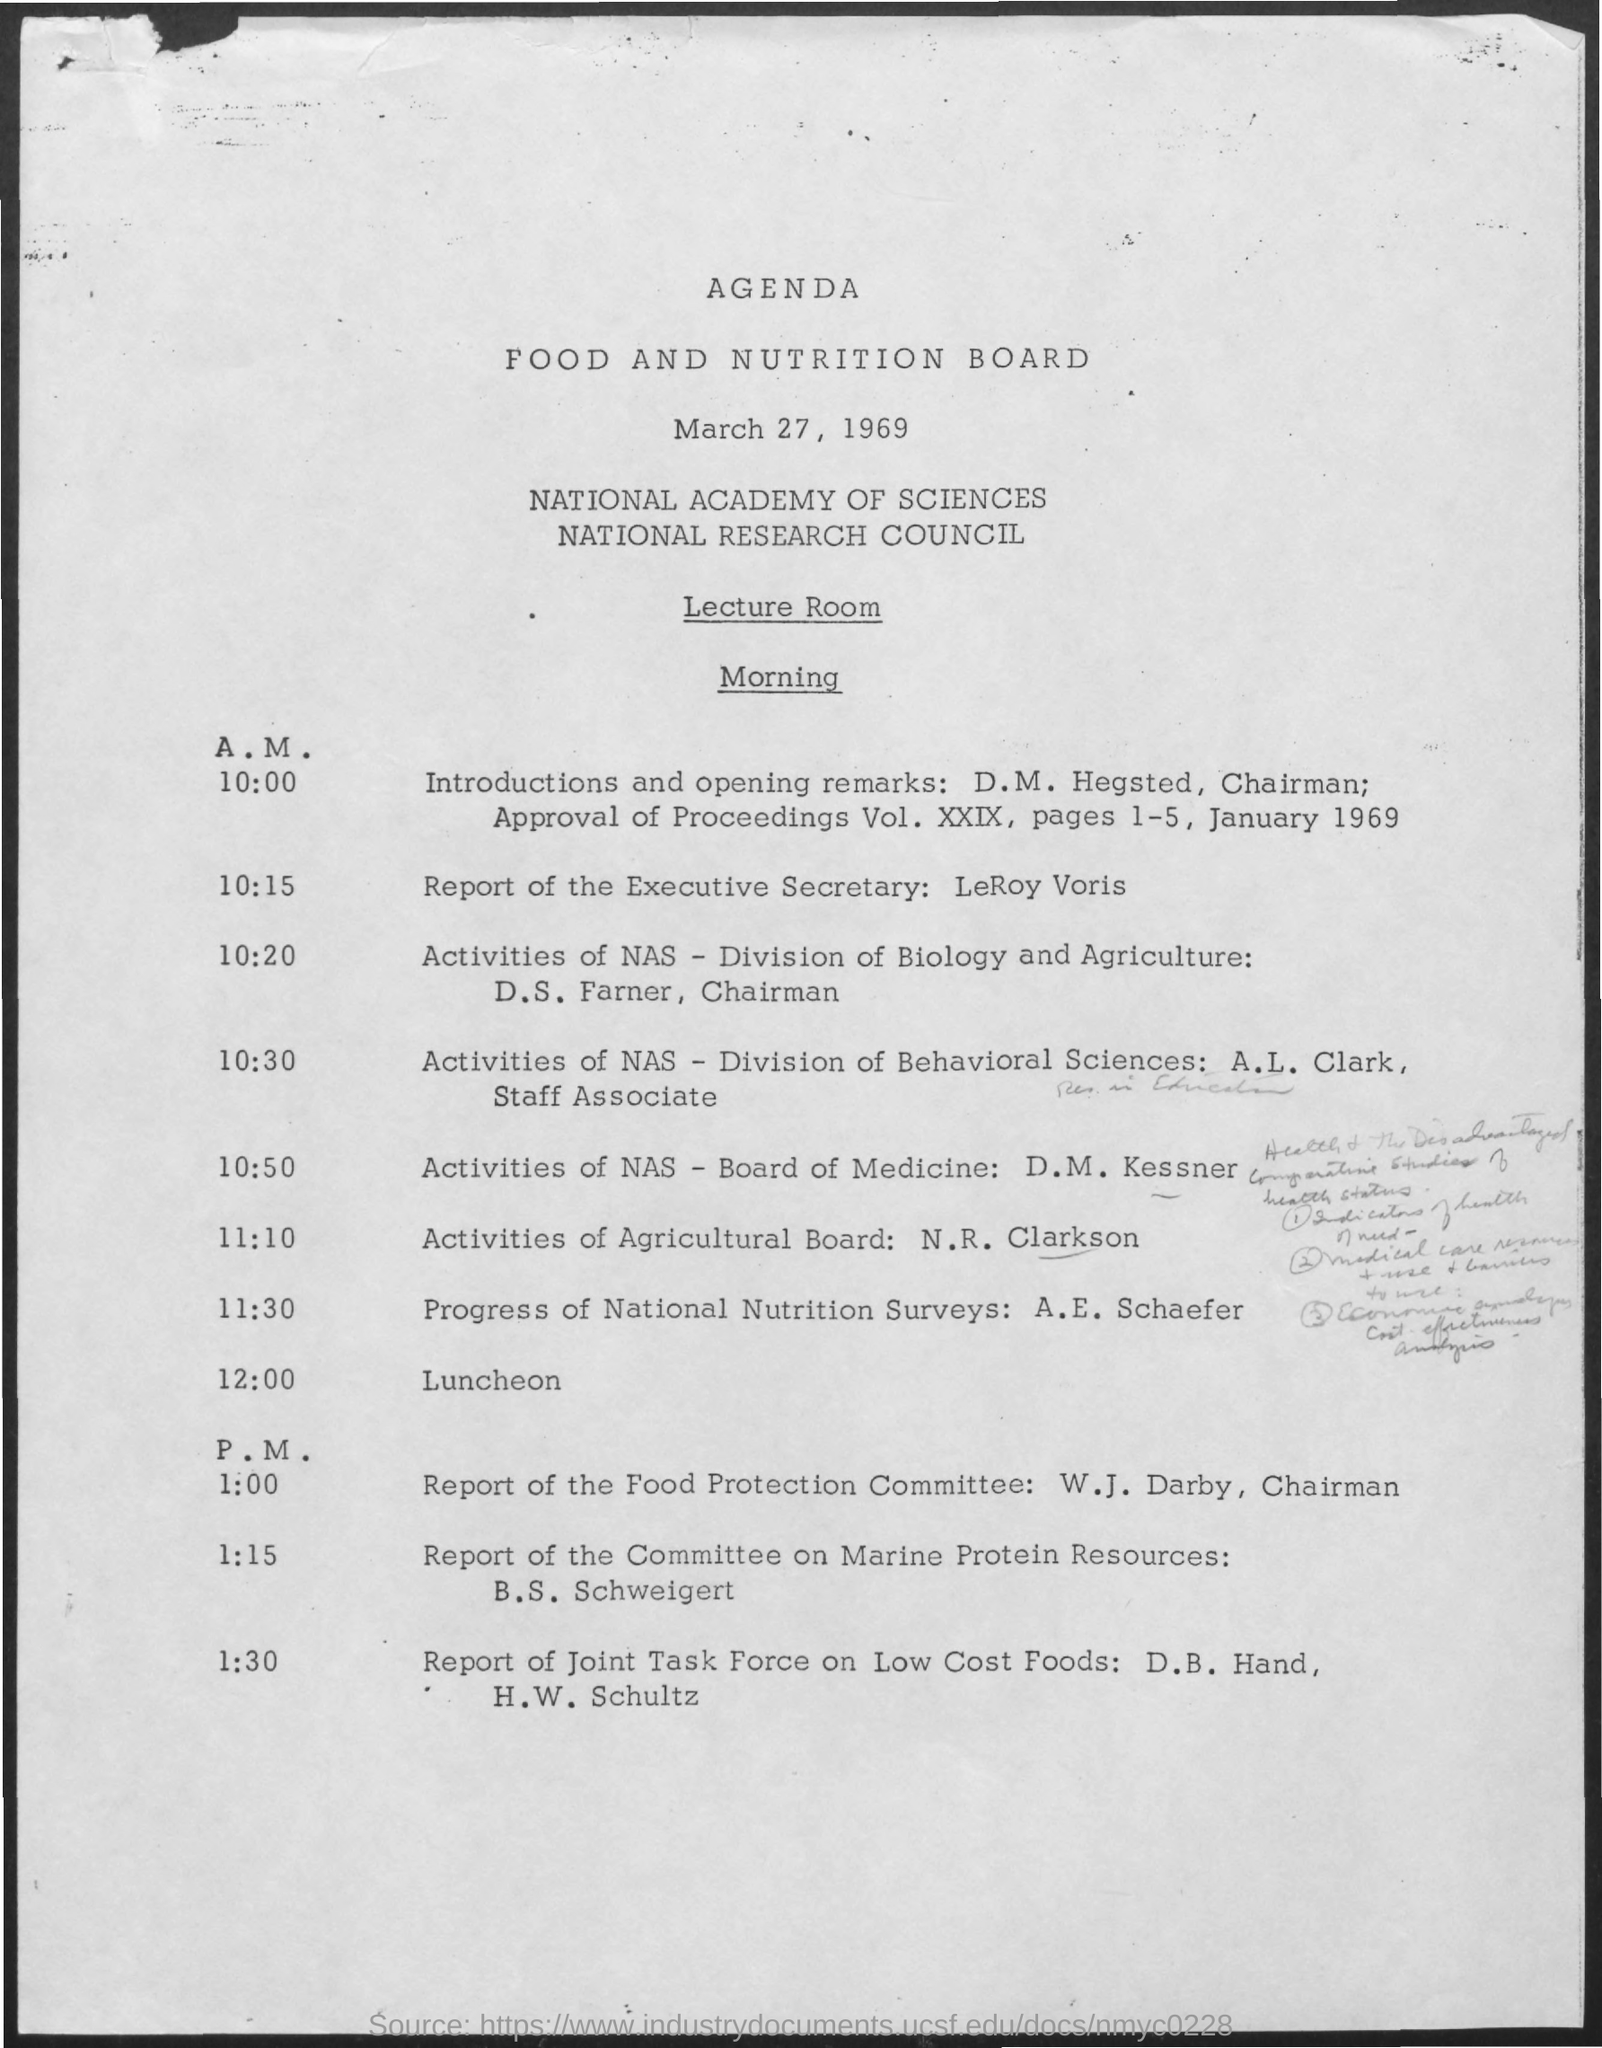What is the date mentioned in the document?
Your answer should be compact. March 27, 1969. 